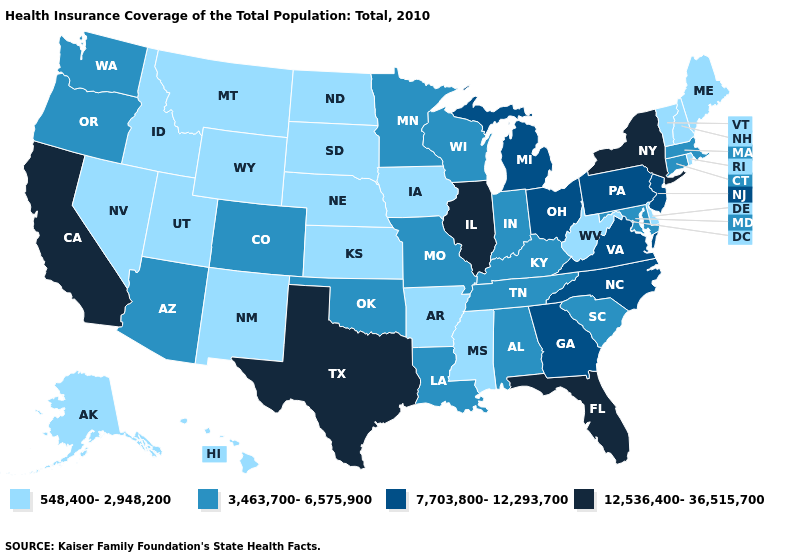What is the value of Maryland?
Concise answer only. 3,463,700-6,575,900. Name the states that have a value in the range 7,703,800-12,293,700?
Be succinct. Georgia, Michigan, New Jersey, North Carolina, Ohio, Pennsylvania, Virginia. Which states have the lowest value in the MidWest?
Write a very short answer. Iowa, Kansas, Nebraska, North Dakota, South Dakota. Does Nevada have the lowest value in the USA?
Give a very brief answer. Yes. Which states have the lowest value in the South?
Give a very brief answer. Arkansas, Delaware, Mississippi, West Virginia. Name the states that have a value in the range 3,463,700-6,575,900?
Answer briefly. Alabama, Arizona, Colorado, Connecticut, Indiana, Kentucky, Louisiana, Maryland, Massachusetts, Minnesota, Missouri, Oklahoma, Oregon, South Carolina, Tennessee, Washington, Wisconsin. What is the value of South Carolina?
Short answer required. 3,463,700-6,575,900. Name the states that have a value in the range 12,536,400-36,515,700?
Keep it brief. California, Florida, Illinois, New York, Texas. Name the states that have a value in the range 7,703,800-12,293,700?
Short answer required. Georgia, Michigan, New Jersey, North Carolina, Ohio, Pennsylvania, Virginia. Does the map have missing data?
Give a very brief answer. No. What is the lowest value in states that border South Carolina?
Short answer required. 7,703,800-12,293,700. Name the states that have a value in the range 3,463,700-6,575,900?
Concise answer only. Alabama, Arizona, Colorado, Connecticut, Indiana, Kentucky, Louisiana, Maryland, Massachusetts, Minnesota, Missouri, Oklahoma, Oregon, South Carolina, Tennessee, Washington, Wisconsin. What is the value of Nevada?
Answer briefly. 548,400-2,948,200. Is the legend a continuous bar?
Quick response, please. No. Does Utah have the lowest value in the USA?
Short answer required. Yes. 